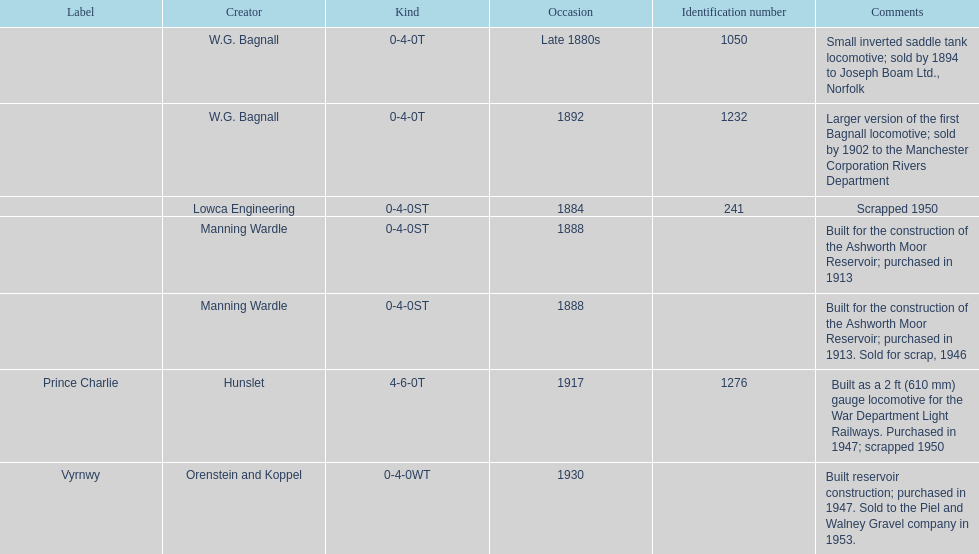How many locomotives were built after 1900? 2. 